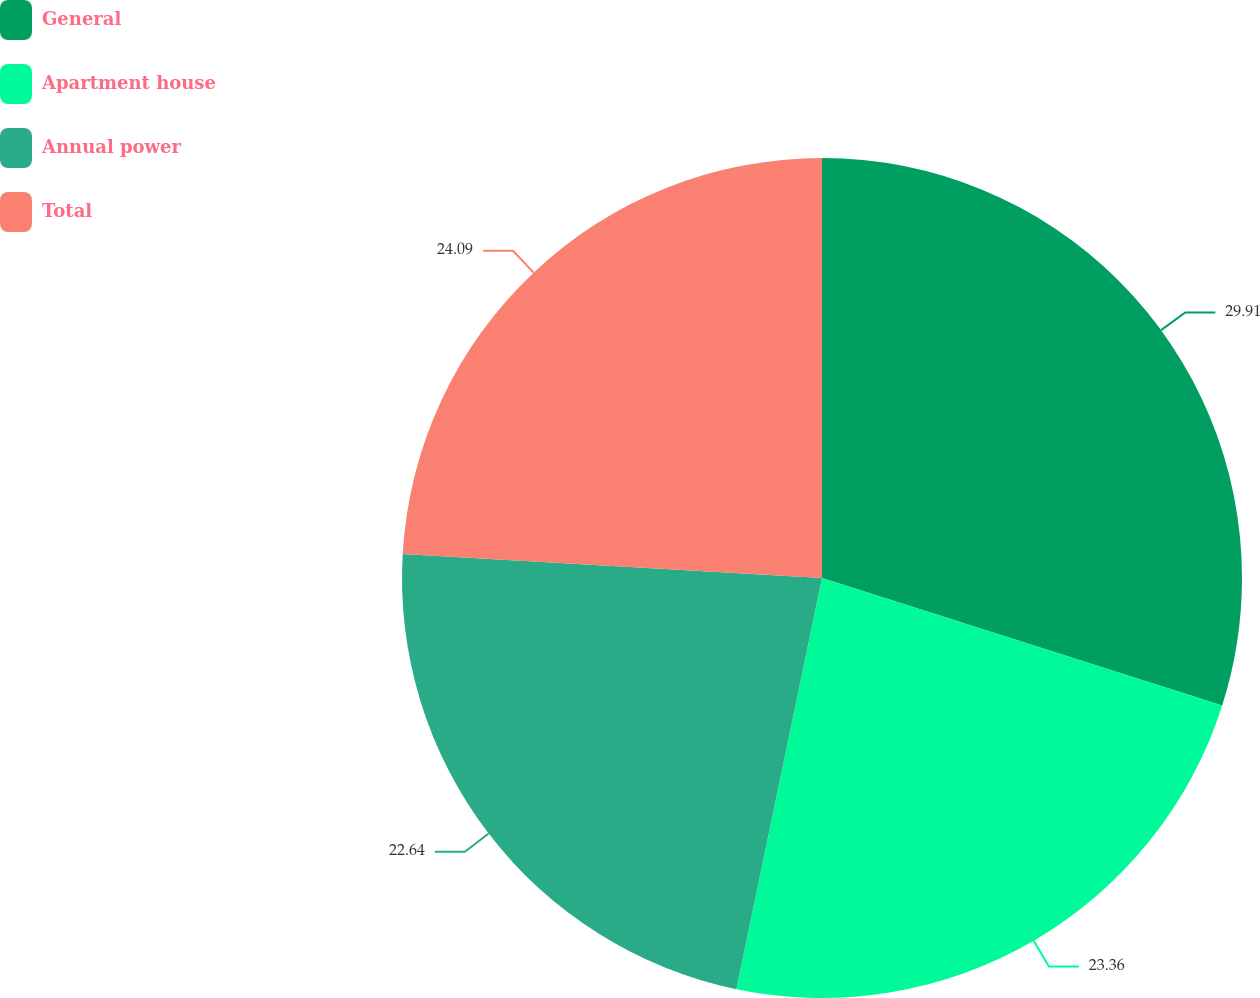Convert chart. <chart><loc_0><loc_0><loc_500><loc_500><pie_chart><fcel>General<fcel>Apartment house<fcel>Annual power<fcel>Total<nl><fcel>29.91%<fcel>23.36%<fcel>22.64%<fcel>24.09%<nl></chart> 